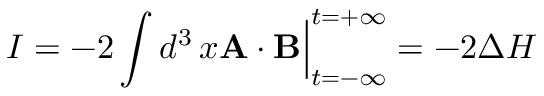Convert formula to latex. <formula><loc_0><loc_0><loc_500><loc_500>I = - 2 \int d ^ { 3 } \, x { A } \cdot { B } \Big | _ { t = - \infty } ^ { t = + \infty } = - 2 \Delta H</formula> 